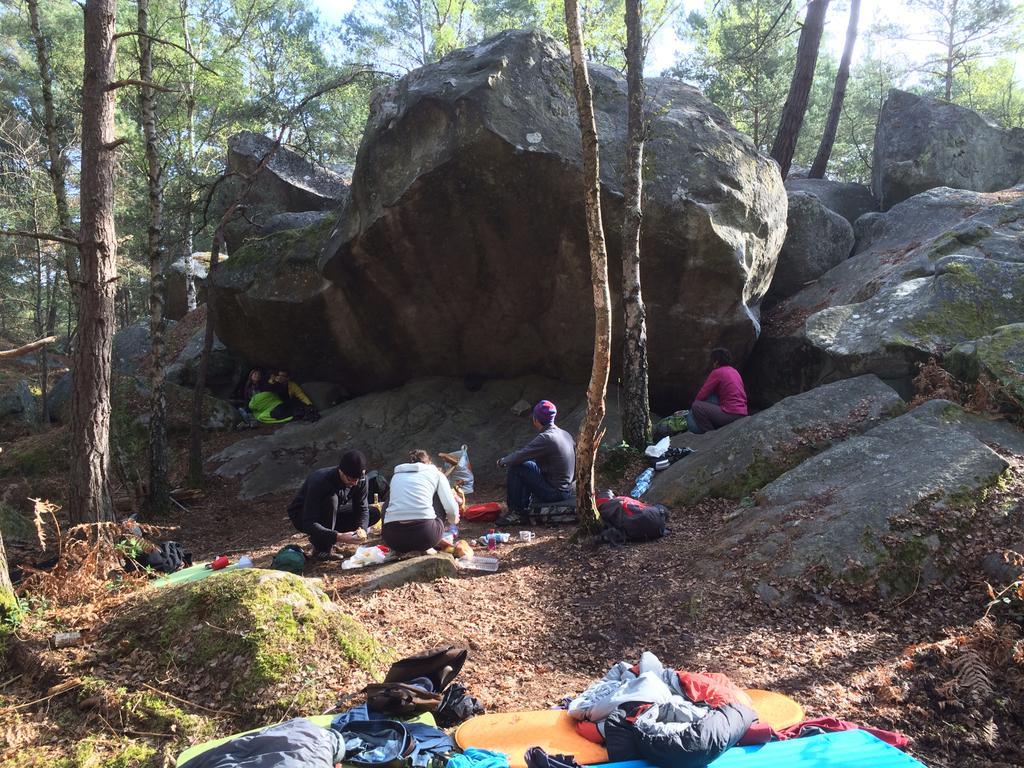Can you describe this image briefly? In this image we can see few people. There are rocks and trees. And also there are bags and some other things. 